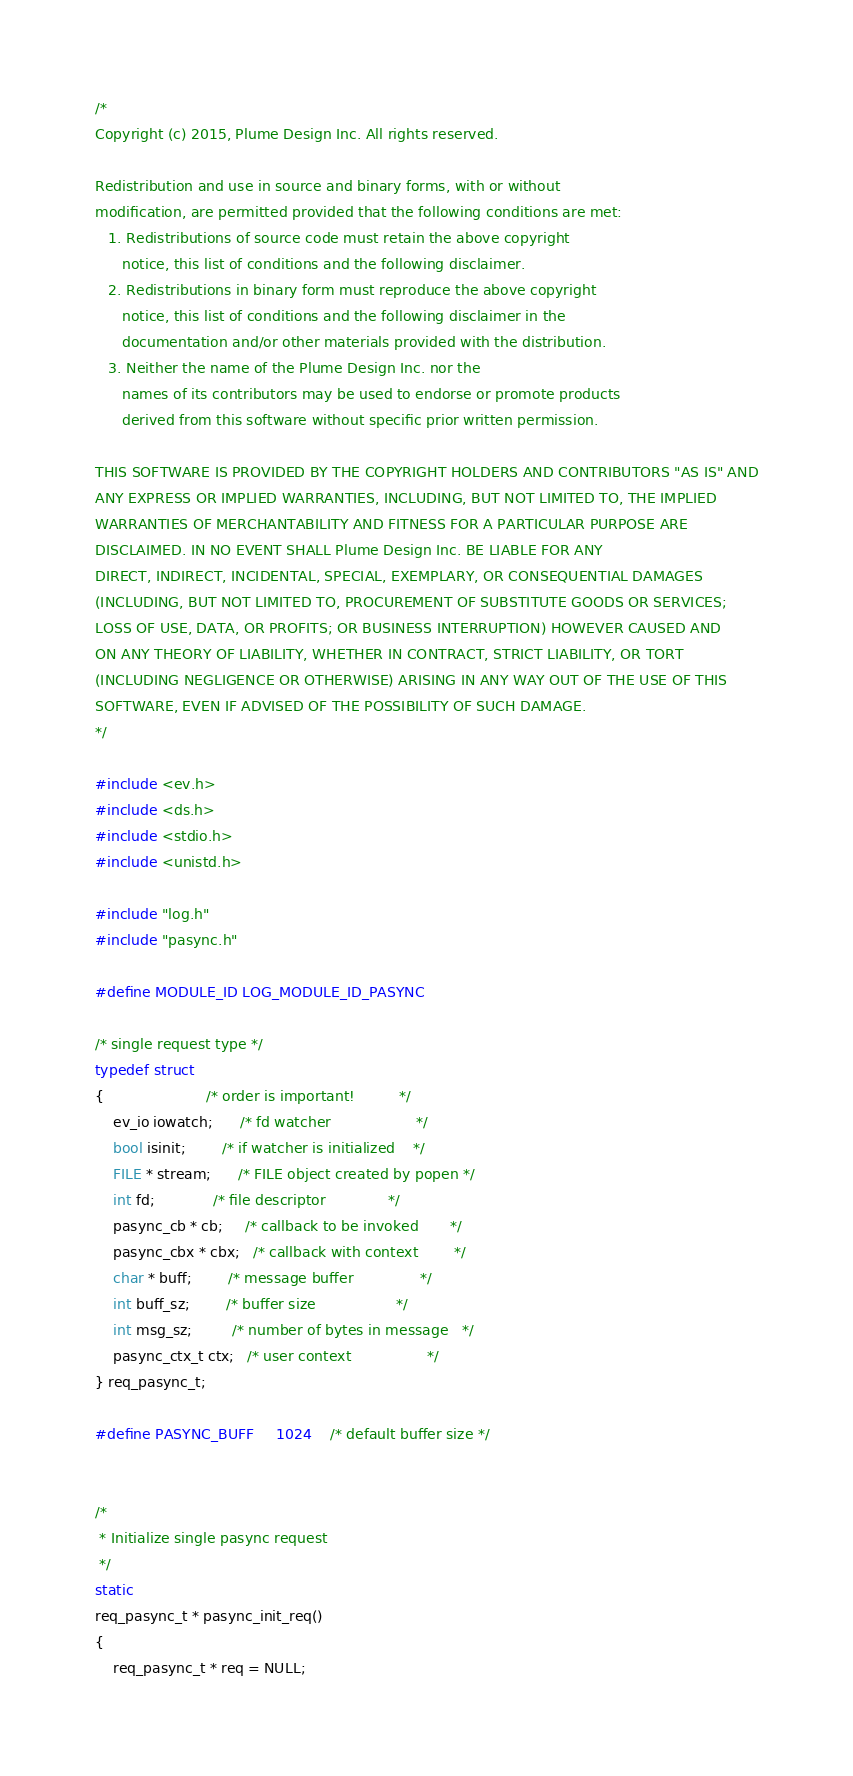Convert code to text. <code><loc_0><loc_0><loc_500><loc_500><_C_>/*
Copyright (c) 2015, Plume Design Inc. All rights reserved.

Redistribution and use in source and binary forms, with or without
modification, are permitted provided that the following conditions are met:
   1. Redistributions of source code must retain the above copyright
      notice, this list of conditions and the following disclaimer.
   2. Redistributions in binary form must reproduce the above copyright
      notice, this list of conditions and the following disclaimer in the
      documentation and/or other materials provided with the distribution.
   3. Neither the name of the Plume Design Inc. nor the
      names of its contributors may be used to endorse or promote products
      derived from this software without specific prior written permission.

THIS SOFTWARE IS PROVIDED BY THE COPYRIGHT HOLDERS AND CONTRIBUTORS "AS IS" AND
ANY EXPRESS OR IMPLIED WARRANTIES, INCLUDING, BUT NOT LIMITED TO, THE IMPLIED
WARRANTIES OF MERCHANTABILITY AND FITNESS FOR A PARTICULAR PURPOSE ARE
DISCLAIMED. IN NO EVENT SHALL Plume Design Inc. BE LIABLE FOR ANY
DIRECT, INDIRECT, INCIDENTAL, SPECIAL, EXEMPLARY, OR CONSEQUENTIAL DAMAGES
(INCLUDING, BUT NOT LIMITED TO, PROCUREMENT OF SUBSTITUTE GOODS OR SERVICES;
LOSS OF USE, DATA, OR PROFITS; OR BUSINESS INTERRUPTION) HOWEVER CAUSED AND
ON ANY THEORY OF LIABILITY, WHETHER IN CONTRACT, STRICT LIABILITY, OR TORT
(INCLUDING NEGLIGENCE OR OTHERWISE) ARISING IN ANY WAY OUT OF THE USE OF THIS
SOFTWARE, EVEN IF ADVISED OF THE POSSIBILITY OF SUCH DAMAGE.
*/

#include <ev.h>
#include <ds.h>
#include <stdio.h>
#include <unistd.h>

#include "log.h"
#include "pasync.h"

#define MODULE_ID LOG_MODULE_ID_PASYNC

/* single request type */
typedef struct
{                       /* order is important!          */
    ev_io iowatch;      /* fd watcher                   */
    bool isinit;        /* if watcher is initialized    */
    FILE * stream;      /* FILE object created by popen */
    int fd;             /* file descriptor              */
    pasync_cb * cb;     /* callback to be invoked       */
    pasync_cbx * cbx;   /* callback with context        */
    char * buff;        /* message buffer               */
    int buff_sz;        /* buffer size                  */
    int msg_sz;         /* number of bytes in message   */
    pasync_ctx_t ctx;   /* user context                 */
} req_pasync_t;

#define PASYNC_BUFF     1024    /* default buffer size */


/*
 * Initialize single pasync request
 */
static
req_pasync_t * pasync_init_req()
{
    req_pasync_t * req = NULL;
</code> 